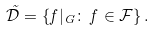<formula> <loc_0><loc_0><loc_500><loc_500>\tilde { \mathcal { D } } = \left \{ f | _ { G } \colon \, f \in \mathcal { F } \right \} .</formula> 